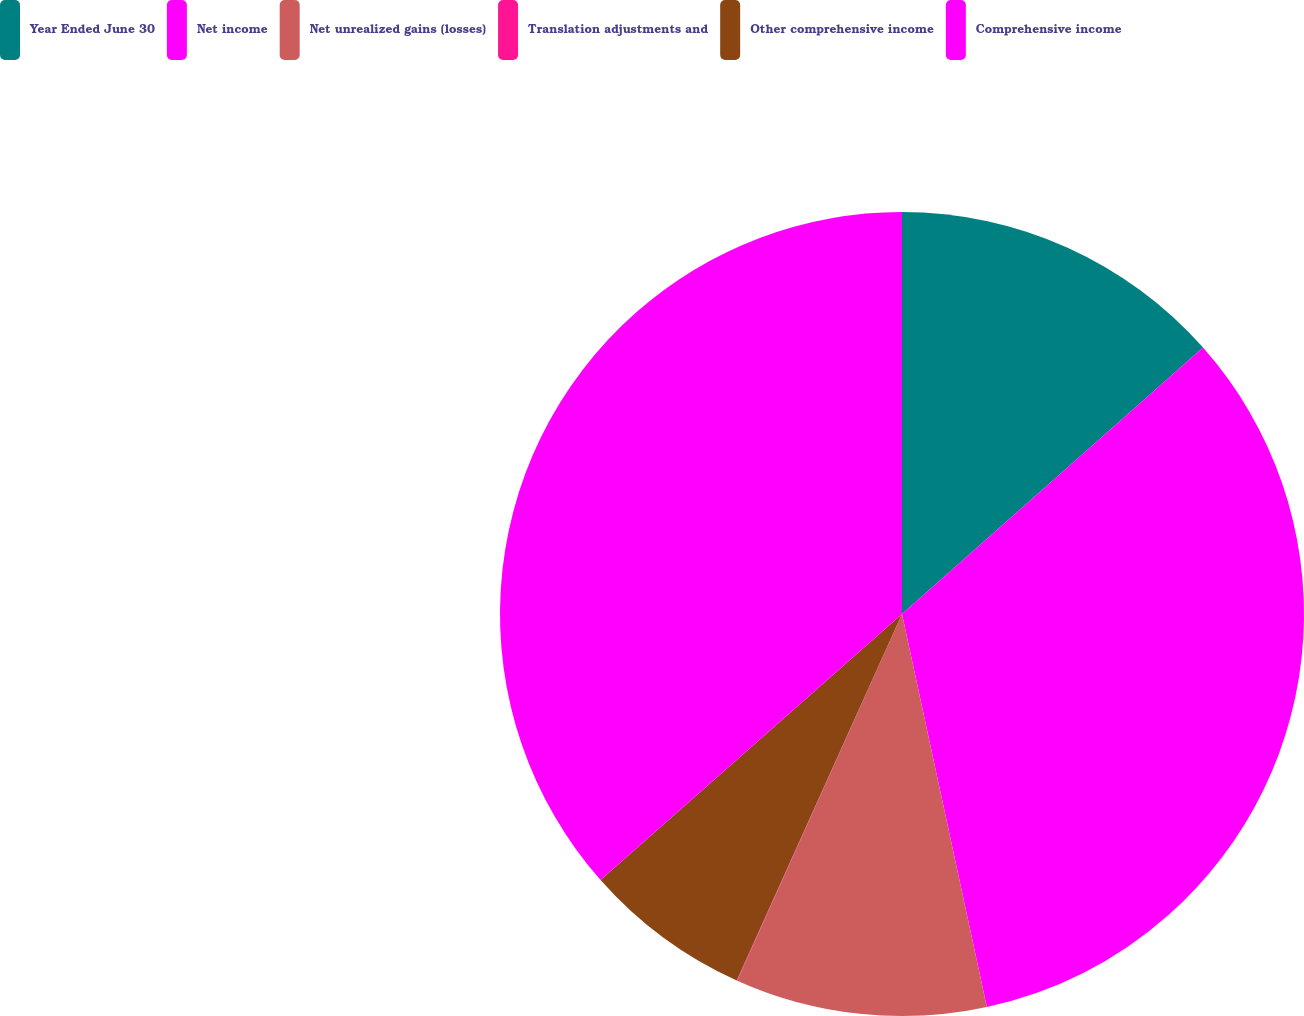Convert chart. <chart><loc_0><loc_0><loc_500><loc_500><pie_chart><fcel>Year Ended June 30<fcel>Net income<fcel>Net unrealized gains (losses)<fcel>Translation adjustments and<fcel>Other comprehensive income<fcel>Comprehensive income<nl><fcel>13.47%<fcel>33.15%<fcel>10.11%<fcel>0.02%<fcel>6.75%<fcel>36.51%<nl></chart> 